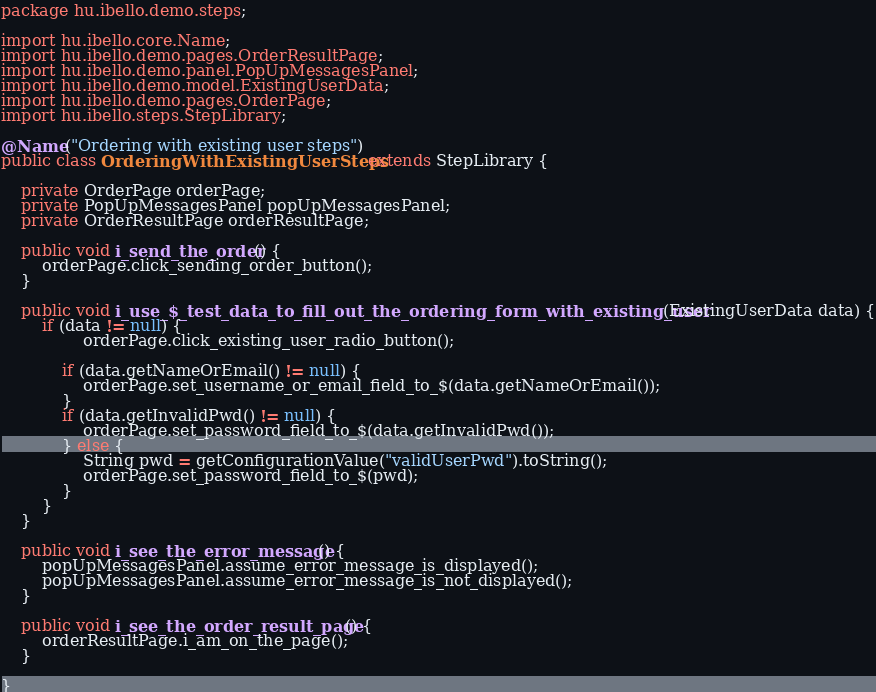<code> <loc_0><loc_0><loc_500><loc_500><_Java_>package hu.ibello.demo.steps;

import hu.ibello.core.Name;
import hu.ibello.demo.pages.OrderResultPage;
import hu.ibello.demo.panel.PopUpMessagesPanel;
import hu.ibello.demo.model.ExistingUserData;
import hu.ibello.demo.pages.OrderPage;
import hu.ibello.steps.StepLibrary;

@Name("Ordering with existing user steps")
public class OrderingWithExistingUserSteps extends StepLibrary {

    private OrderPage orderPage;
    private PopUpMessagesPanel popUpMessagesPanel;
    private OrderResultPage orderResultPage;

    public void i_send_the_order() {
        orderPage.click_sending_order_button();
    }

    public void i_use_$_test_data_to_fill_out_the_ordering_form_with_existing_user(ExistingUserData data) {
        if (data != null) {
                orderPage.click_existing_user_radio_button();

            if (data.getNameOrEmail() != null) {
                orderPage.set_username_or_email_field_to_$(data.getNameOrEmail());
            }
            if (data.getInvalidPwd() != null) {
                orderPage.set_password_field_to_$(data.getInvalidPwd());
            } else {
                String pwd = getConfigurationValue("validUserPwd").toString();
                orderPage.set_password_field_to_$(pwd);
            }
        }
    }

    public void i_see_the_error_message() {
        popUpMessagesPanel.assume_error_message_is_displayed();
        popUpMessagesPanel.assume_error_message_is_not_displayed();
    }

    public void i_see_the_order_result_page() {
        orderResultPage.i_am_on_the_page();
    }

}
</code> 